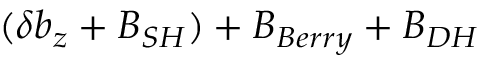Convert formula to latex. <formula><loc_0><loc_0><loc_500><loc_500>( \delta b _ { z } + B _ { S H } ) + B _ { B e r r y } + B _ { D H }</formula> 